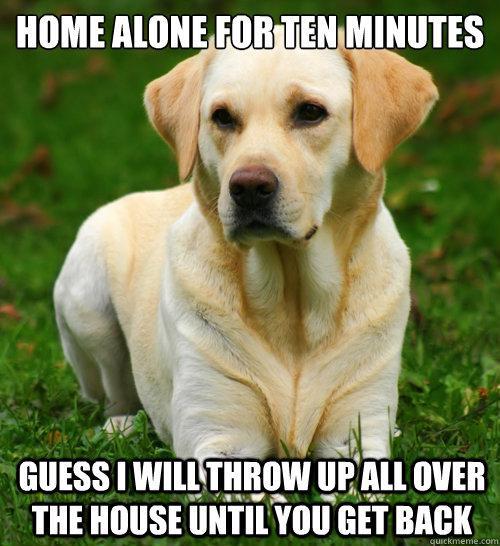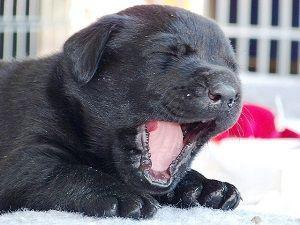The first image is the image on the left, the second image is the image on the right. Analyze the images presented: Is the assertion "There is at least one human touching a dog." valid? Answer yes or no. No. The first image is the image on the left, the second image is the image on the right. Given the left and right images, does the statement "One image shows a lone dog facing the right with his mouth open." hold true? Answer yes or no. Yes. 